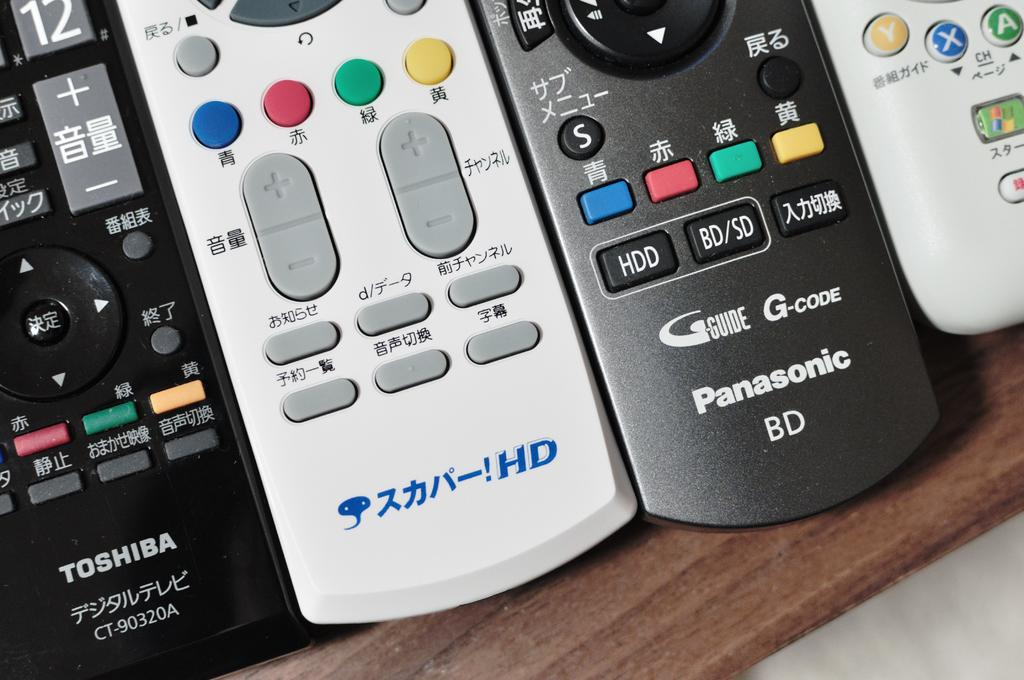<image>
Present a compact description of the photo's key features. Four remote controls with asian lettering on them including Toshiba and Panasonic. 